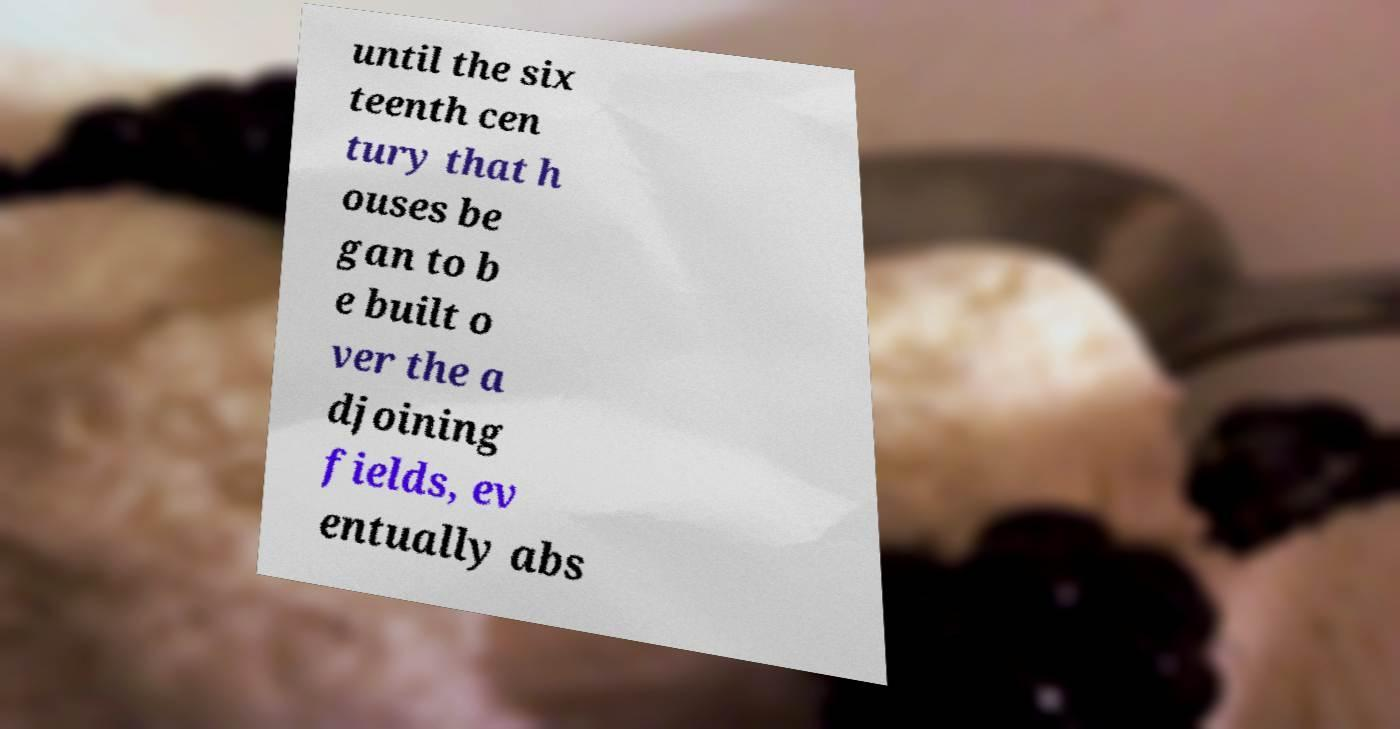I need the written content from this picture converted into text. Can you do that? until the six teenth cen tury that h ouses be gan to b e built o ver the a djoining fields, ev entually abs 